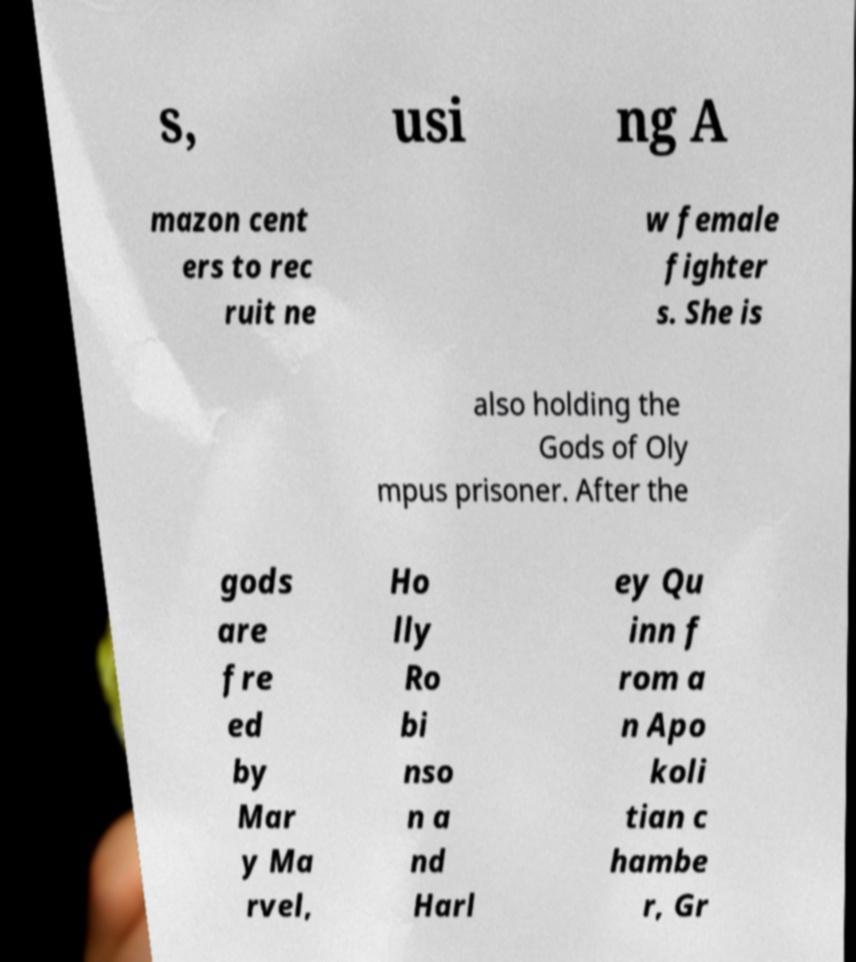There's text embedded in this image that I need extracted. Can you transcribe it verbatim? s, usi ng A mazon cent ers to rec ruit ne w female fighter s. She is also holding the Gods of Oly mpus prisoner. After the gods are fre ed by Mar y Ma rvel, Ho lly Ro bi nso n a nd Harl ey Qu inn f rom a n Apo koli tian c hambe r, Gr 